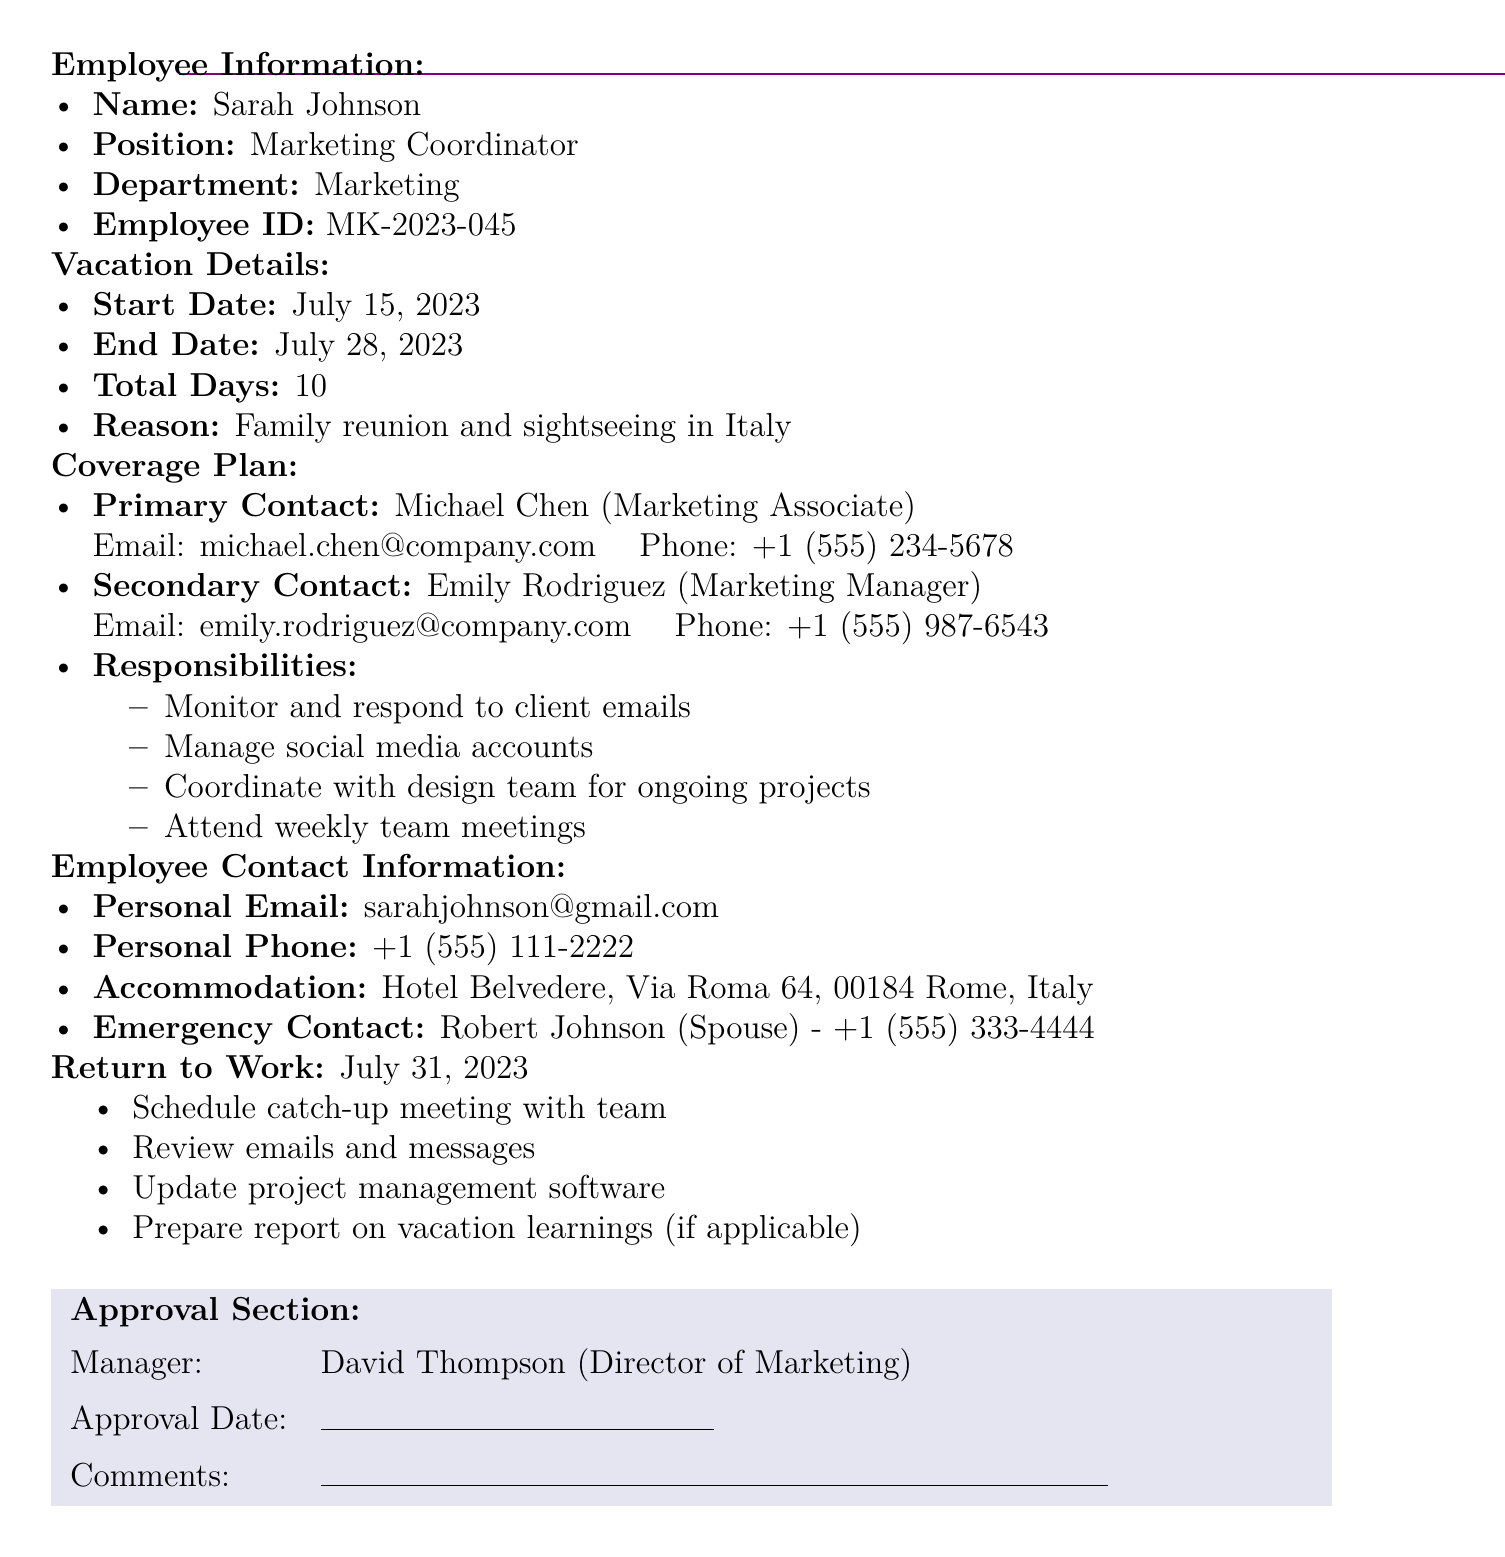What are the vacation start and end dates? The start date is July 15, 2023, and the end date is July 28, 2023.
Answer: July 15, 2023; July 28, 2023 Who is the primary contact during the vacation? The primary contact is Michael Chen, who is a Marketing Associate.
Answer: Michael Chen What is the main reason for the vacation? The document states that the reason is for a family reunion and sightseeing in Italy.
Answer: Family reunion and sightseeing in Italy How many total days of vacation is requested? The total days of vacation mentioned in the document is 10 days.
Answer: 10 When is the employee scheduled to return to work? The return to work date listed in the document is July 31, 2023.
Answer: July 31, 2023 Who is the emergency contact for the employee? The document lists Robert Johnson as the emergency contact.
Answer: Robert Johnson What responsibilities will the primary contact handle? The primary contact will monitor and respond to client emails, manage social media accounts, coordinate with the design team, and attend weekly team meetings.
Answer: Monitor emails, manage social media, coordinate with design team, attend meetings What is the accommodation address during the vacation? The accommodation listed in the document is Hotel Belvedere, Via Roma 64, 00184 Rome, Italy.
Answer: Hotel Belvedere, Via Roma 64, 00184 Rome, Italy Who needs to approve the vacation request? The document indicates that David Thompson, the Director of Marketing, needs to approve the vacation request.
Answer: David Thompson 